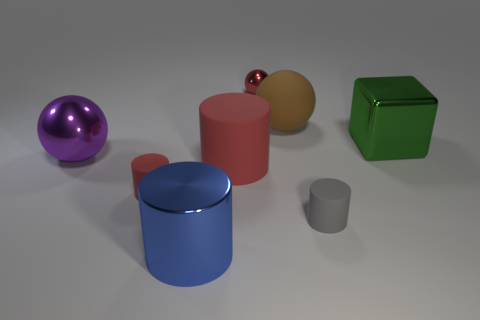Add 2 rubber spheres. How many objects exist? 10 Subtract all balls. How many objects are left? 5 Add 4 tiny matte cylinders. How many tiny matte cylinders are left? 6 Add 7 big green shiny balls. How many big green shiny balls exist? 7 Subtract 0 red cubes. How many objects are left? 8 Subtract all blue blocks. Subtract all red shiny balls. How many objects are left? 7 